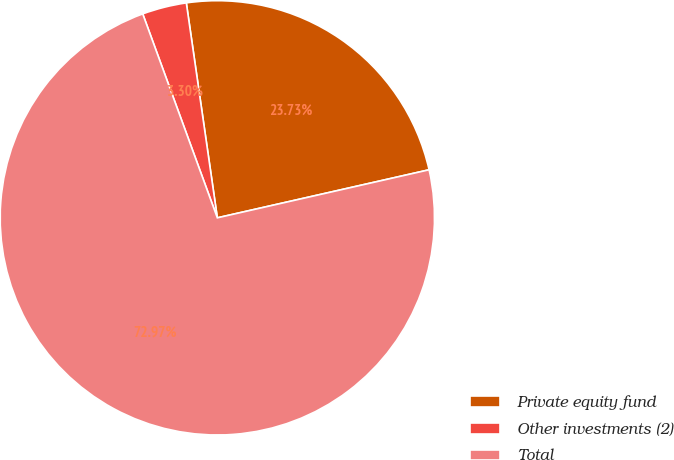Convert chart to OTSL. <chart><loc_0><loc_0><loc_500><loc_500><pie_chart><fcel>Private equity fund<fcel>Other investments (2)<fcel>Total<nl><fcel>23.73%<fcel>3.3%<fcel>72.97%<nl></chart> 